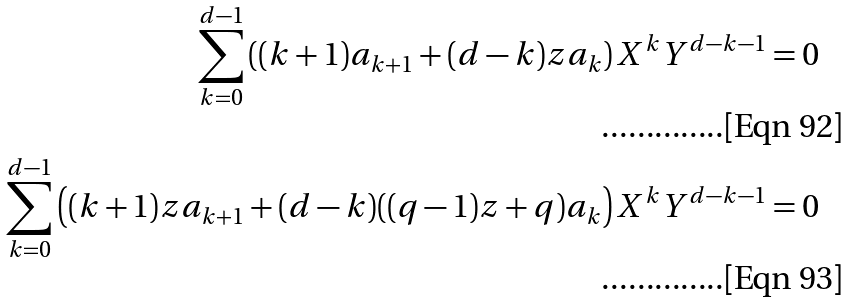Convert formula to latex. <formula><loc_0><loc_0><loc_500><loc_500>\sum _ { k = 0 } ^ { d - 1 } \left ( ( k + 1 ) a _ { k + 1 } + ( d - k ) z a _ { k } \right ) X ^ { k } Y ^ { d - k - 1 } = 0 \\ \sum _ { k = 0 } ^ { d - 1 } \left ( ( k + 1 ) z a _ { k + 1 } + ( d - k ) ( ( q - 1 ) z + q ) a _ { k } \right ) X ^ { k } Y ^ { d - k - 1 } = 0</formula> 